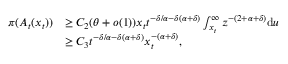Convert formula to latex. <formula><loc_0><loc_0><loc_500><loc_500>\begin{array} { r l } { \pi ( A _ { t } ( x _ { t } ) ) } & { \geq C _ { 2 } ( \theta + o ( 1 ) ) x _ { t } t ^ { - \delta / \alpha - \delta ( \alpha + \delta ) } \int _ { x _ { t } } ^ { \infty } z ^ { - ( 2 + \alpha + \delta ) } d u } \\ & { \geq C _ { 3 } t ^ { - \delta / \alpha - \delta ( \alpha + \delta ) } x _ { t } ^ { - ( \alpha + \delta ) } , } \end{array}</formula> 